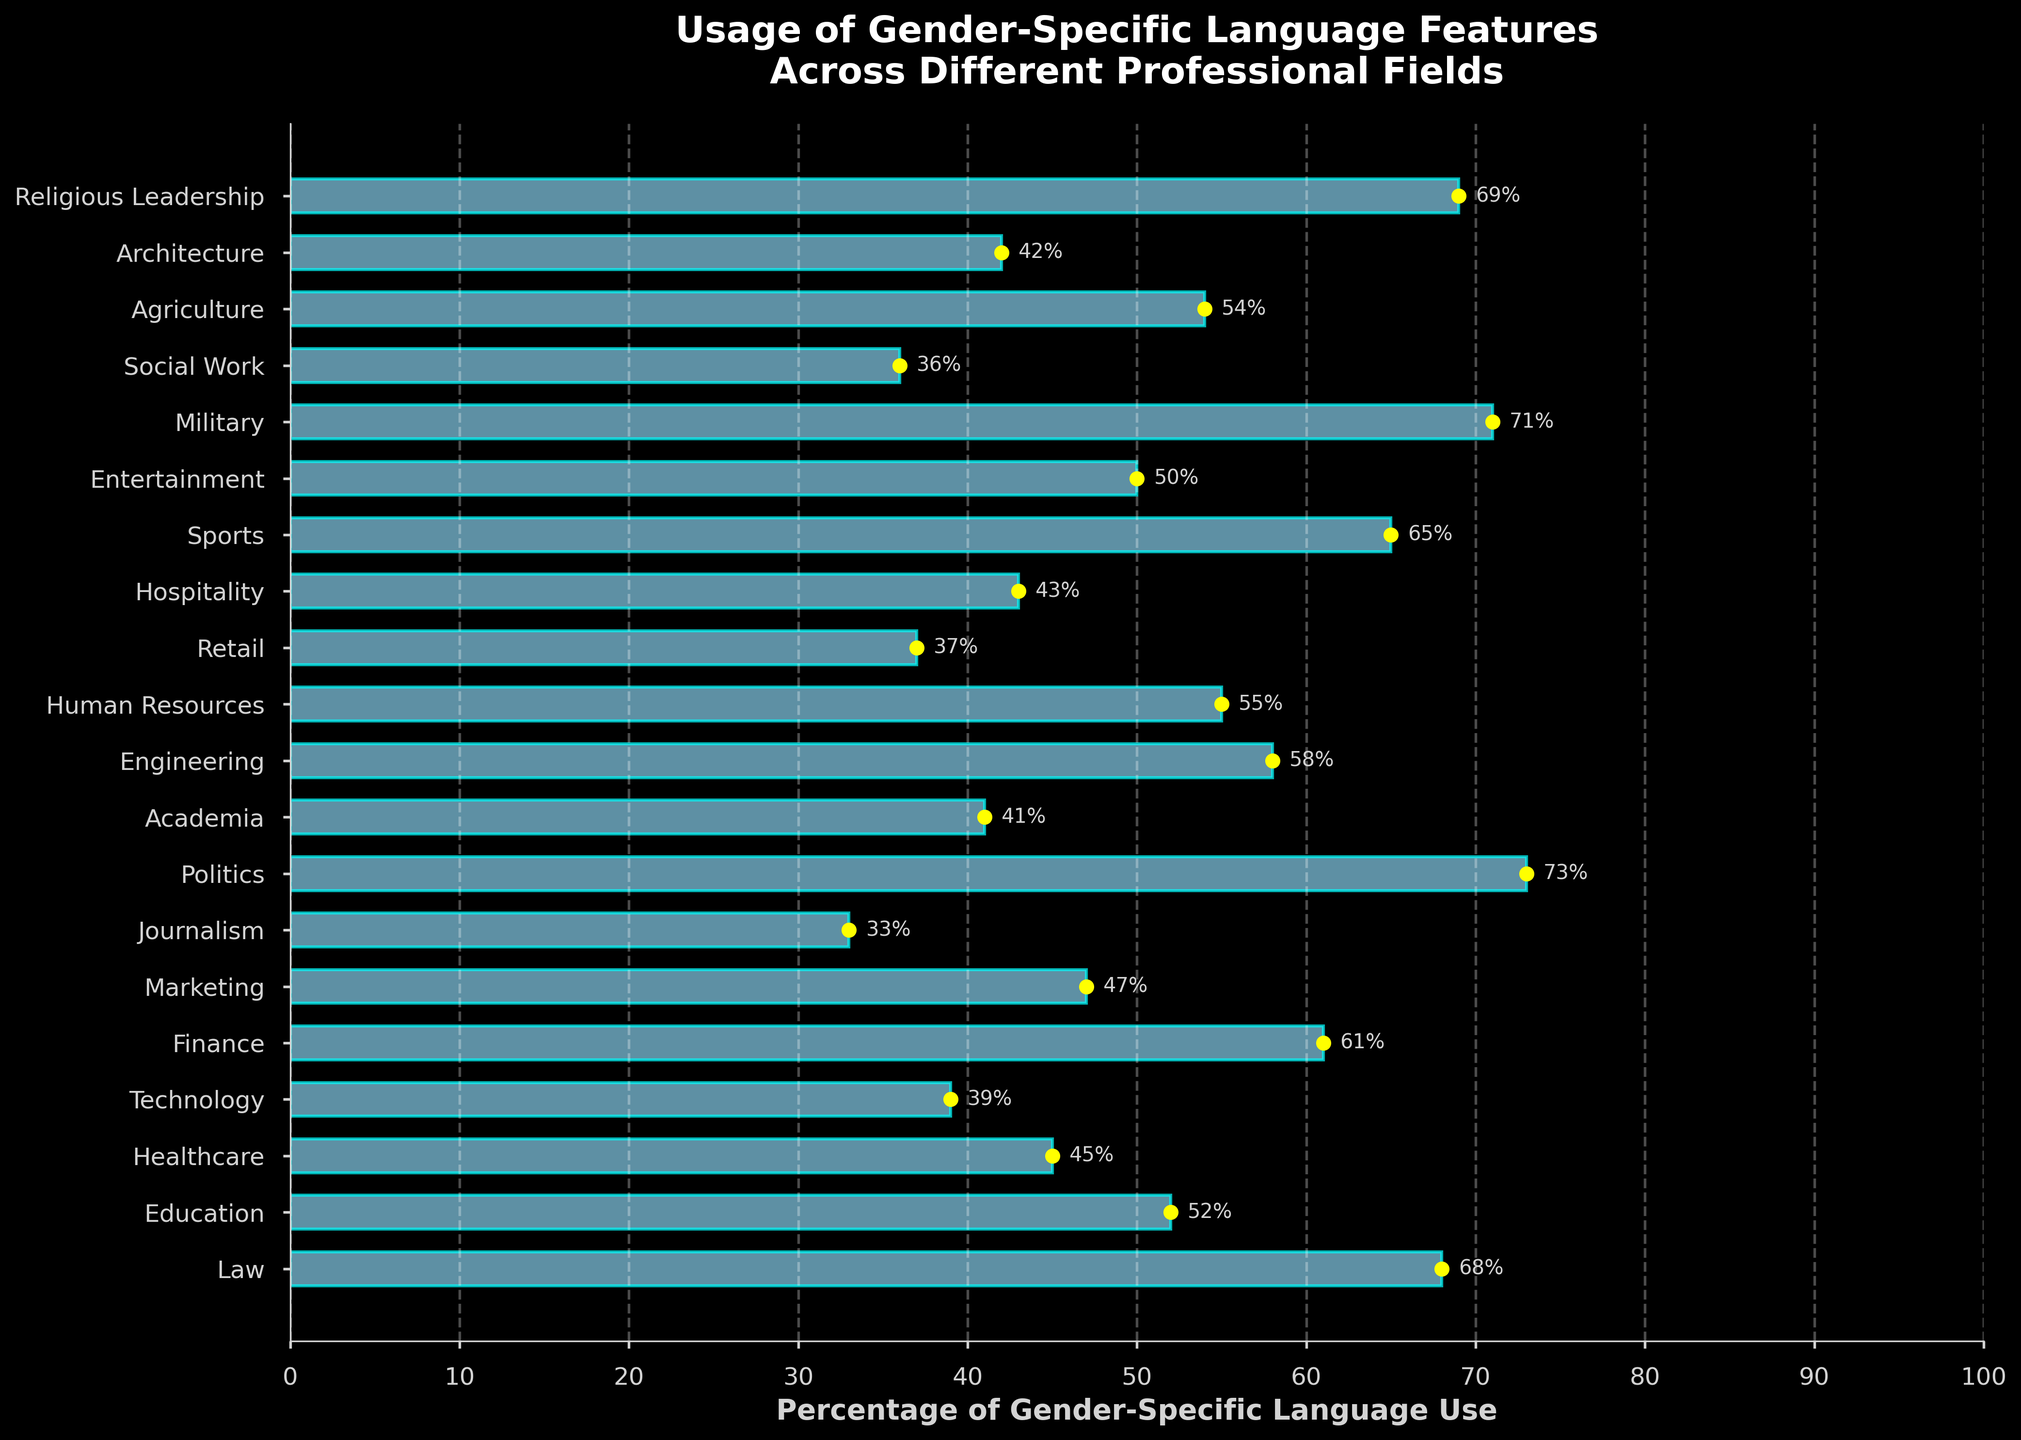Which professional field has the highest percentage of gender-specific language use? By observing the length of the bars, the field with the longest bar is Politics, indicating the highest percentage
Answer: Politics Which professional field has the lowest percentage of gender-specific language use? By looking at the shortest bar, Journalism has the lowest percentage
Answer: Journalism What is the average percentage of gender-specific language use across Technology, Finance, and Engineering? Adding the percentages (39 + 61 + 58) gives 158. Dividing by 3 gives an average of 52.67
Answer: 52.67 Which field uses gender-specific language features more, Education or Human Resources? Comparing the bar lengths, Education (52) has a slightly lower percentage than Human Resources (55)
Answer: Human Resources Between Healthcare and Social Work, which field shows a lesser percentage of gender-specific language use? Healthcare has a bar showing 45% while Social Work has 36%, so Social Work has a lesser percentage
Answer: Social Work By how much does the percentage of gender-specific language use in Politics exceed that in Technology? Subtracting the values (73 - 39) gives the difference, which is 34
Answer: 34 Is the use of gender-specific language features in Retail more or less than in Academia? By checking the bar lengths, Retail (37) is less than Academia (41)
Answer: Less Which professional field has a higher percentage: Law or Military? Comparing the bars, Military (71) has a slightly higher percentage than Law (68)
Answer: Military Calculate the median percentage of gender-specific language use across all fields listed. Order the percentages and find the middle value. Average the two middle values (50 and 52) gives a median of 51
Answer: 51 How many professional fields have a gender-specific language use percentage greater than 60%? Counting the fields with percentages above 60% (Law, Politics, Military, Religious Leadership, Sports, and Finance) equals 6
Answer: 6 